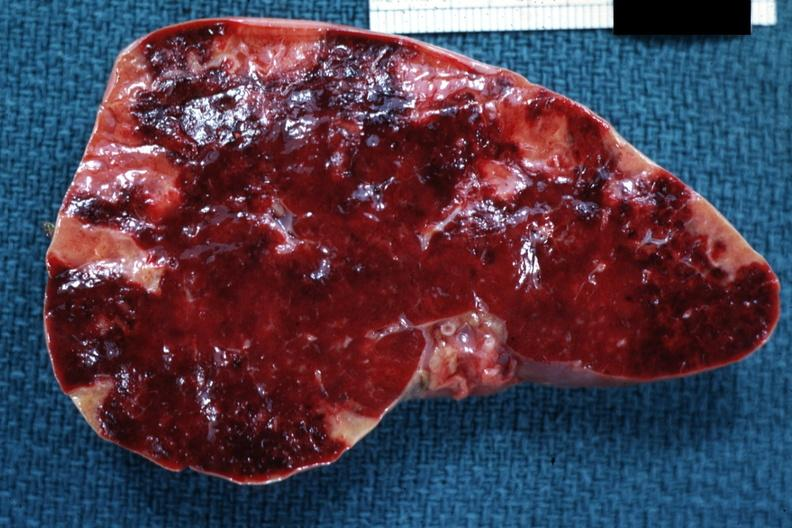s anencephaly present?
Answer the question using a single word or phrase. No 